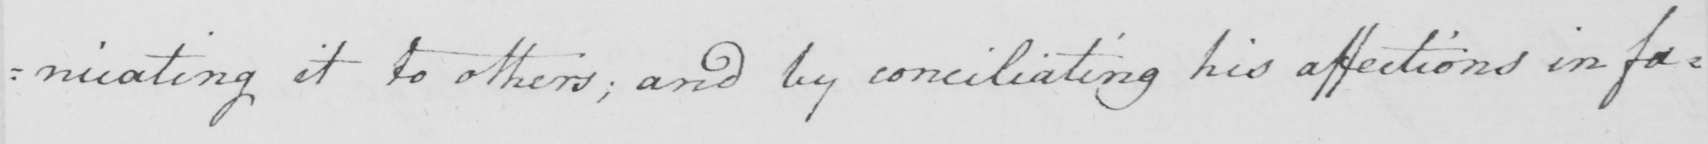Can you read and transcribe this handwriting? it to others ; and by conciliating his affections in favour 